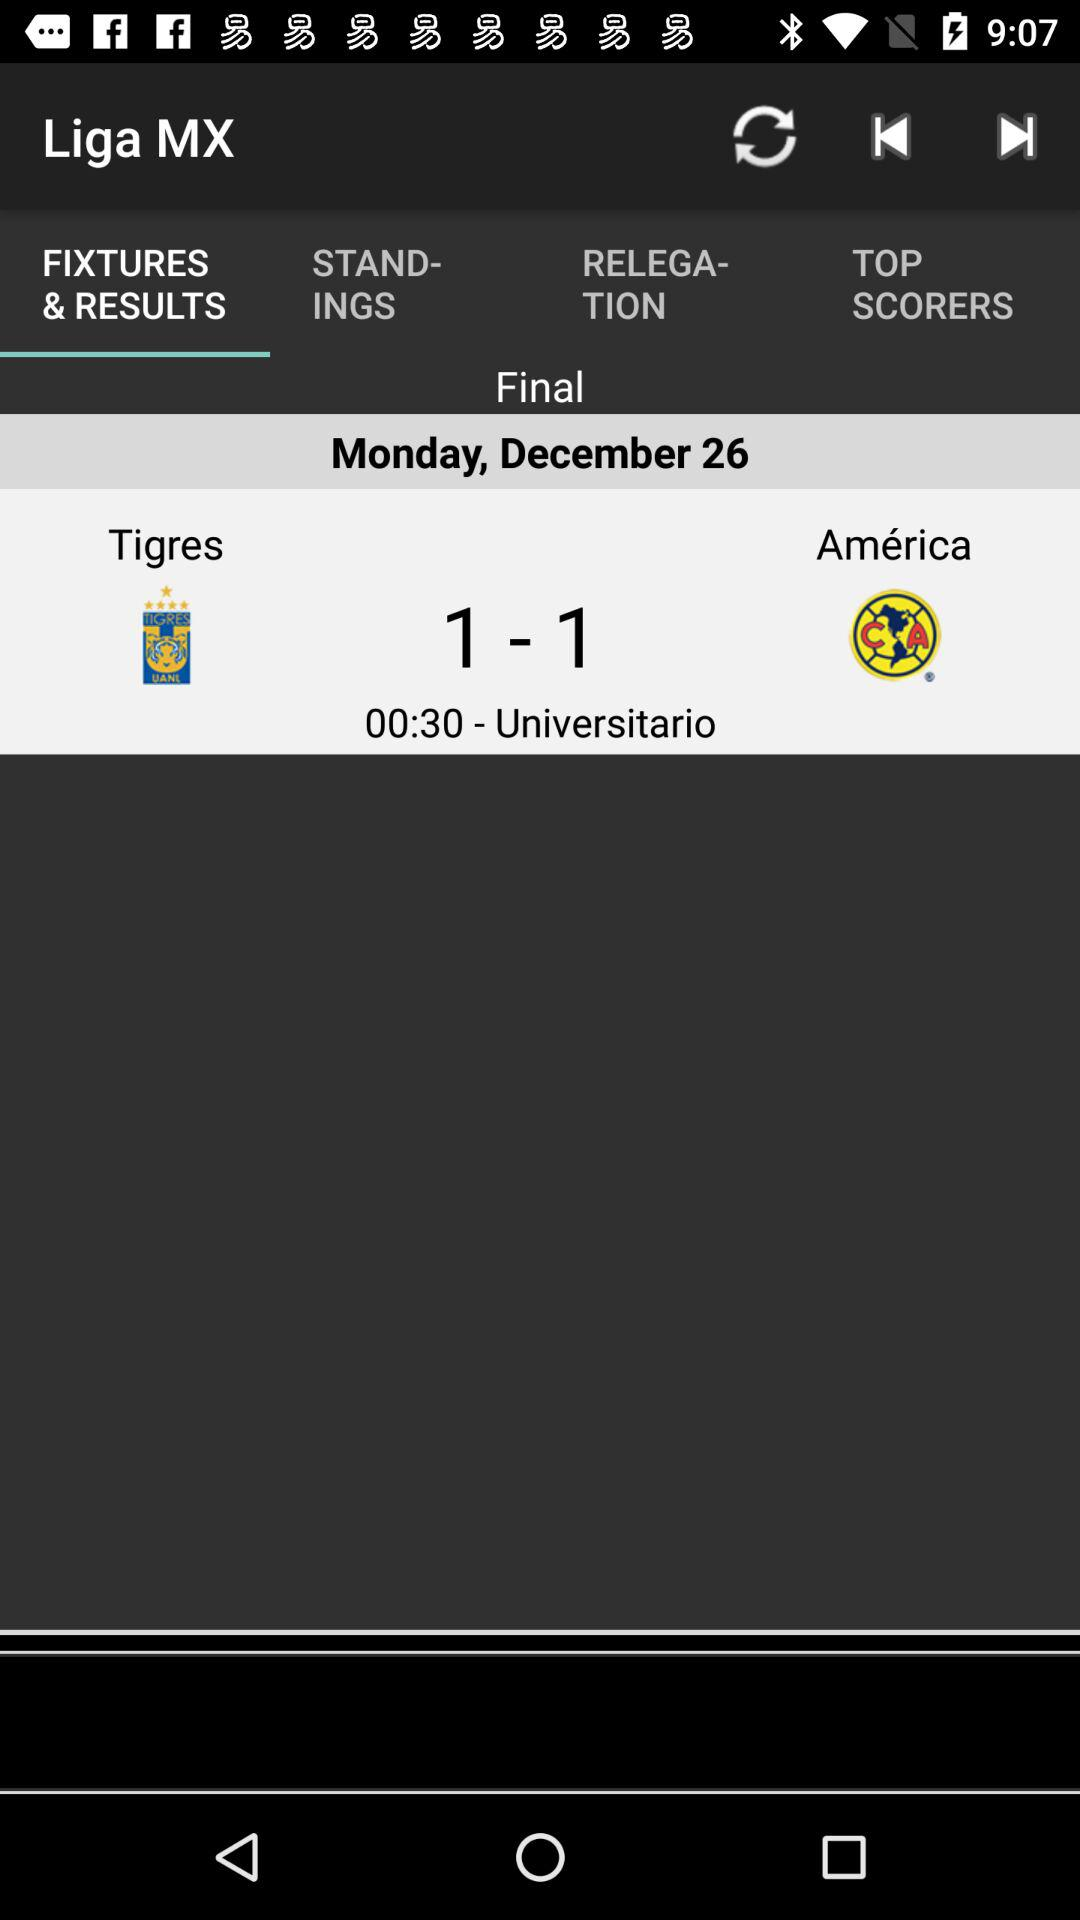When is the final match between "Tigres" and "America"? The final match is on Monday, December 26. 